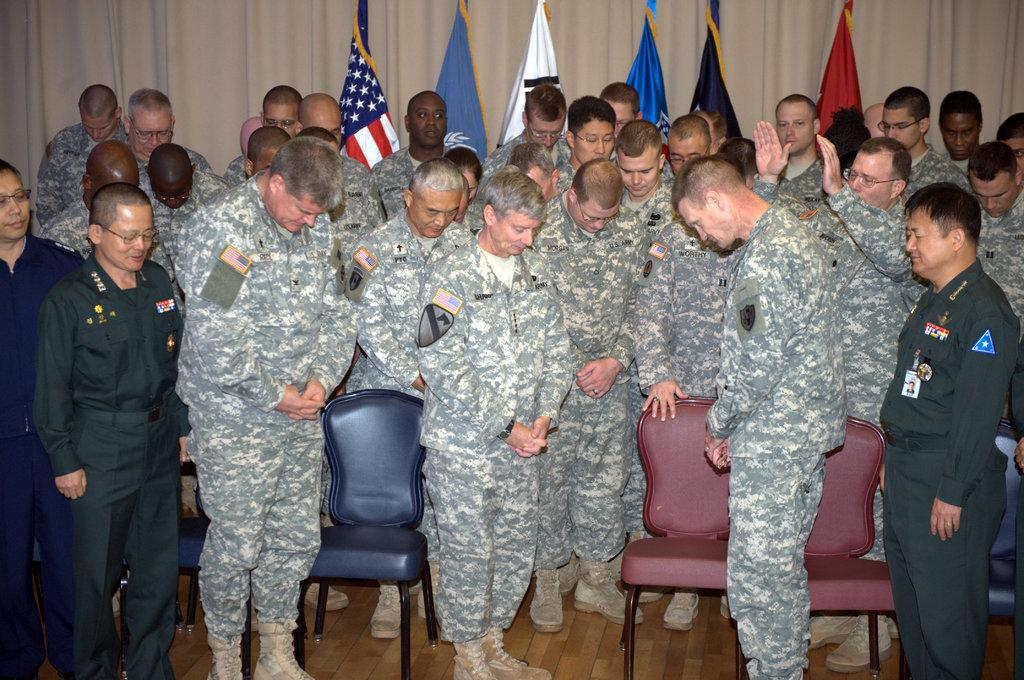What can be seen in the image in terms of human presence? There are people standing in the image. What colors are the chairs in the image? The chairs in the image are red and blue. What type of clothing are most of the people wearing? Most of the people are wearing military dress. What can be seen in the image that represents a symbol or nation? There are flags visible in the image. What type of dinner is being served on the canvas in the image? There is no canvas or dinner present in the image. 